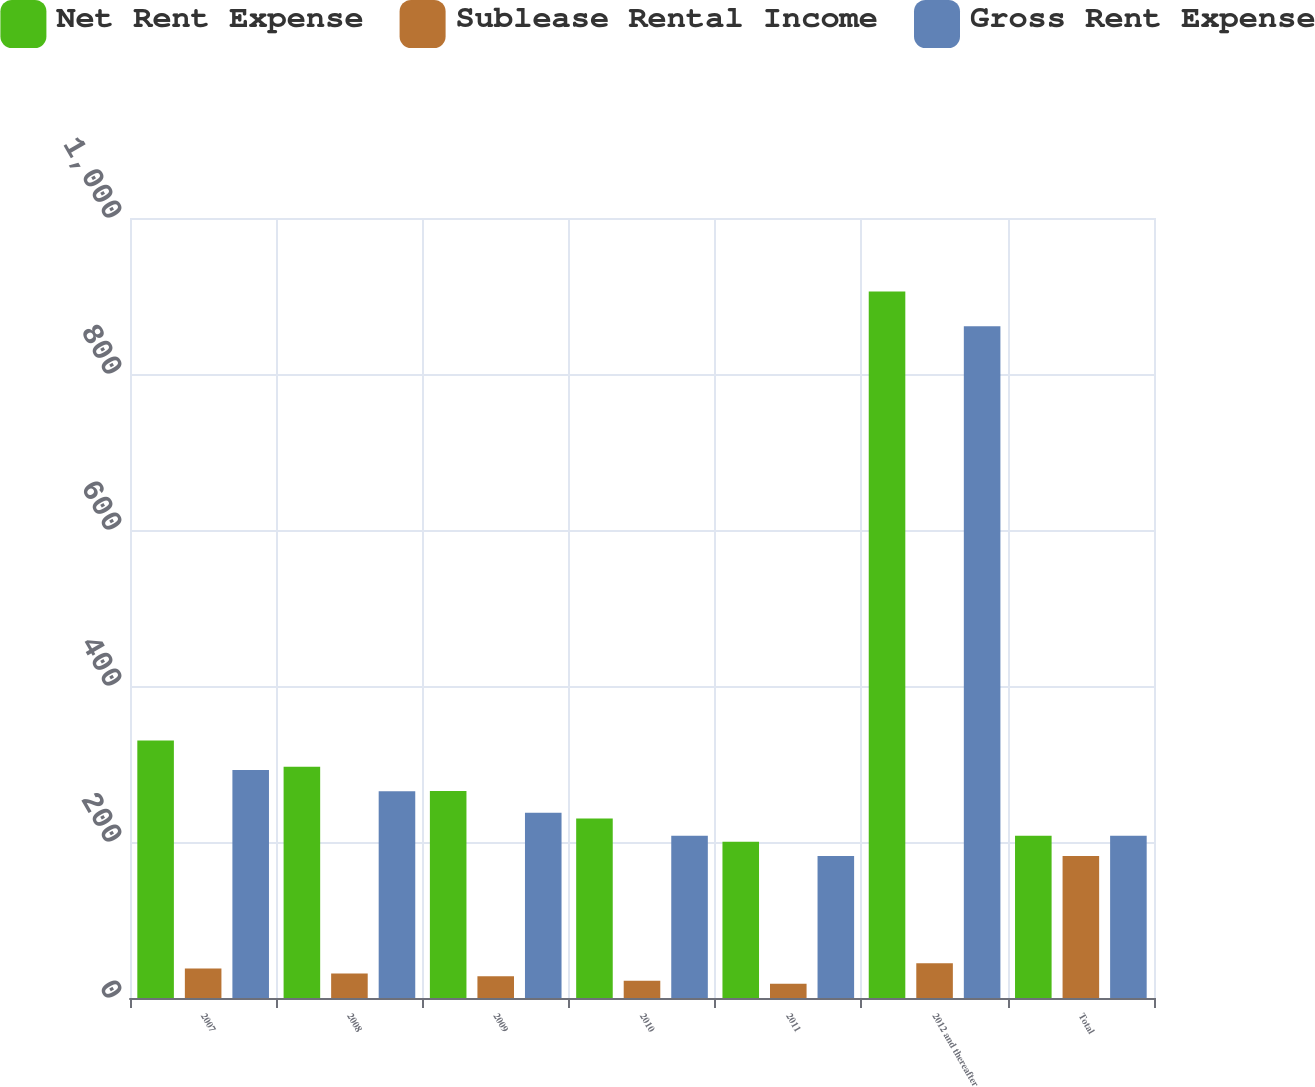Convert chart. <chart><loc_0><loc_0><loc_500><loc_500><stacked_bar_chart><ecel><fcel>2007<fcel>2008<fcel>2009<fcel>2010<fcel>2011<fcel>2012 and thereafter<fcel>Total<nl><fcel>Net Rent Expense<fcel>330.2<fcel>296.5<fcel>265.3<fcel>230<fcel>200.2<fcel>905.8<fcel>207.9<nl><fcel>Sublease Rental Income<fcel>37.9<fcel>31.3<fcel>27.9<fcel>22.1<fcel>18.3<fcel>44.6<fcel>182.1<nl><fcel>Gross Rent Expense<fcel>292.3<fcel>265.2<fcel>237.4<fcel>207.9<fcel>181.9<fcel>861.2<fcel>207.9<nl></chart> 